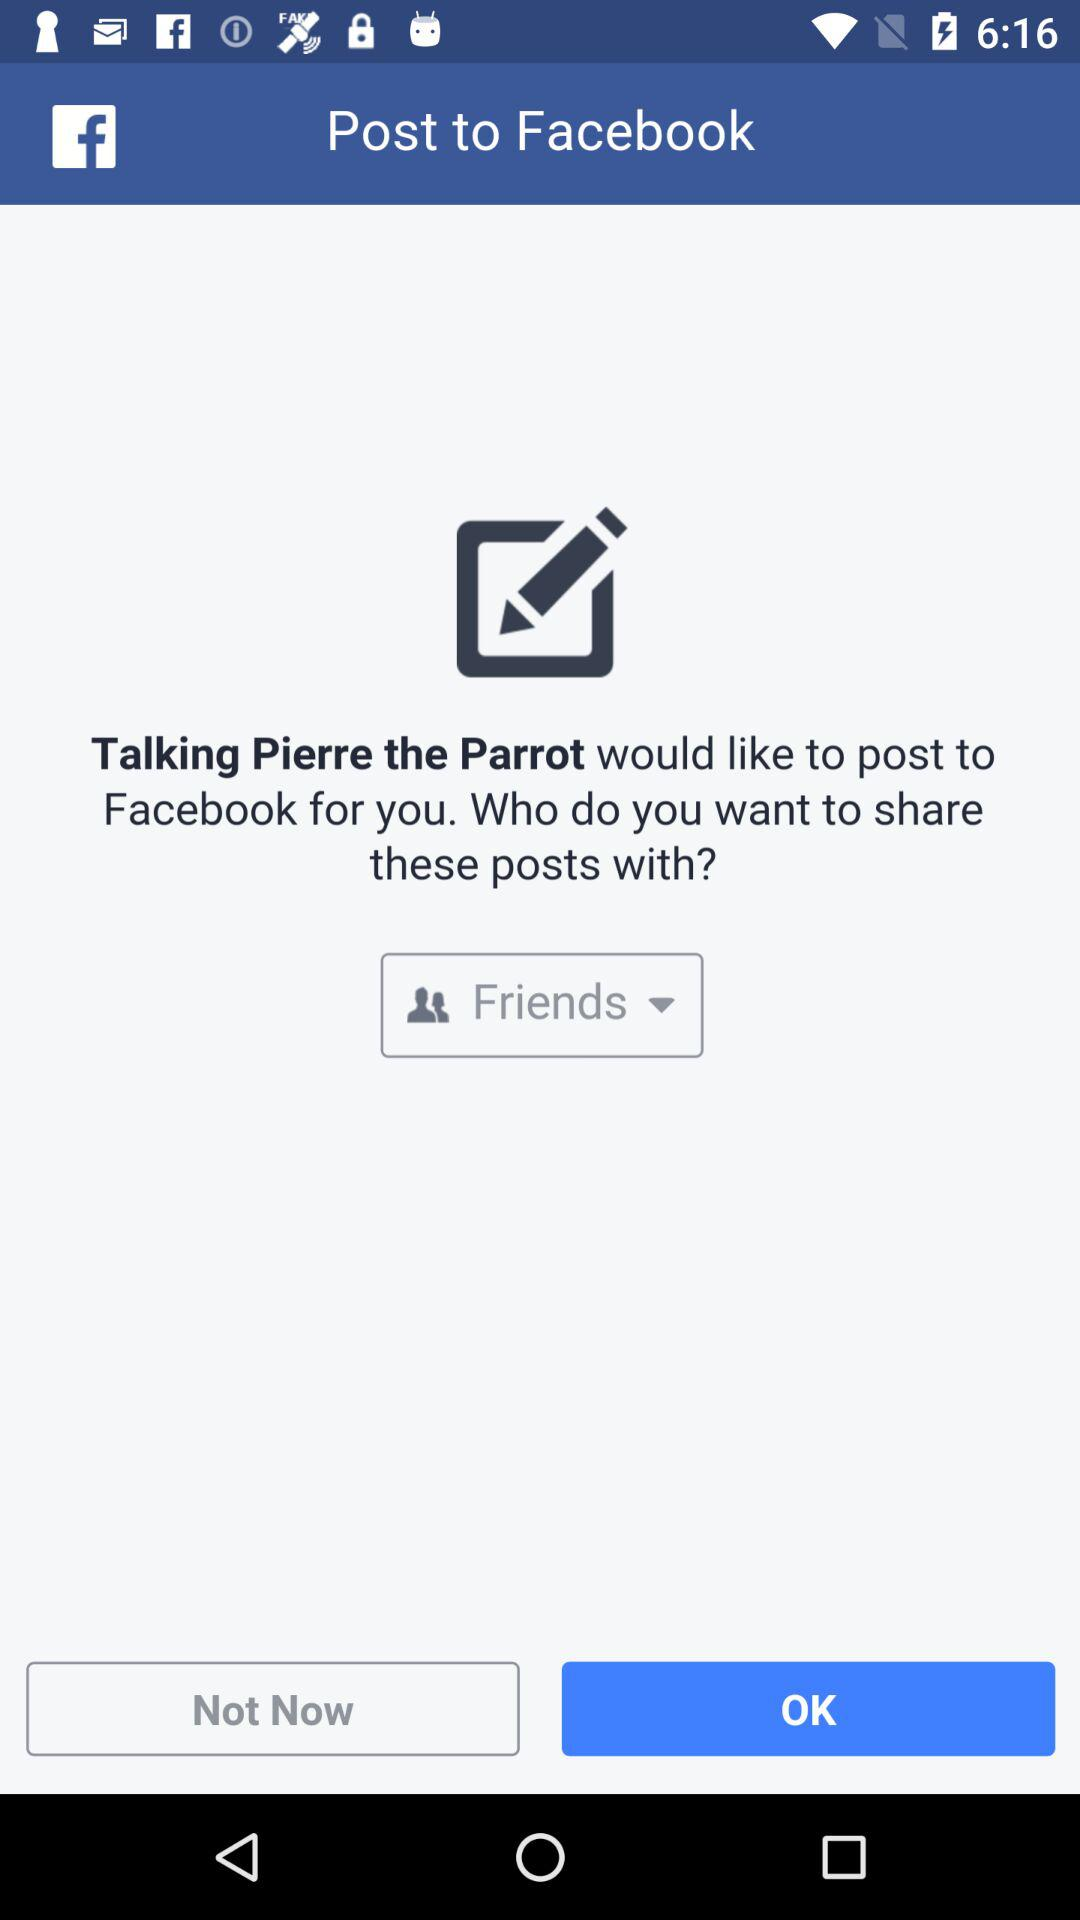Through what application can we post to "Facebook"? You can post to "Facebook" through "Talking Pierre the Parrot". 